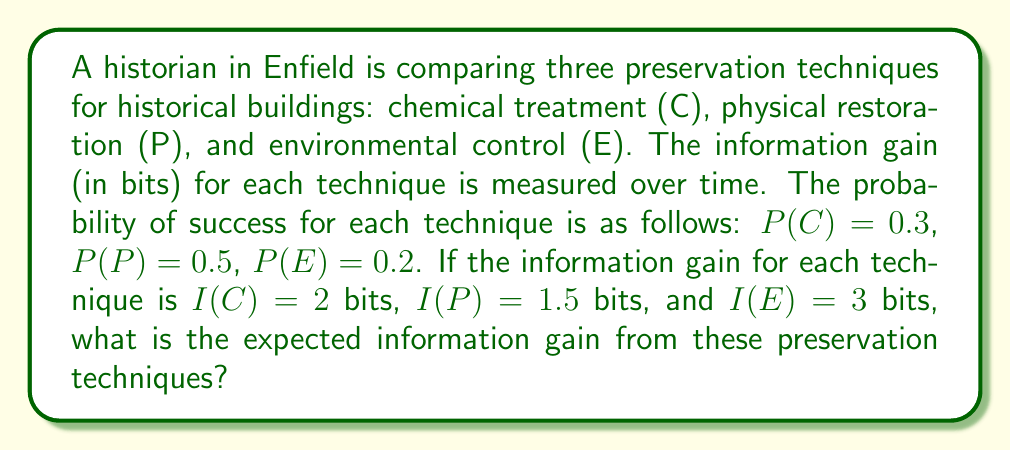What is the answer to this math problem? To solve this problem, we need to calculate the expected information gain using the given probabilities and information gains for each preservation technique. The expected information gain is the sum of the products of each technique's probability and its information gain.

Let's break it down step by step:

1. For chemical treatment (C):
   Probability: P(C) = 0.3
   Information gain: I(C) = 2 bits
   Expected gain from C: $E(C) = P(C) \times I(C) = 0.3 \times 2 = 0.6$ bits

2. For physical restoration (P):
   Probability: P(P) = 0.5
   Information gain: I(P) = 1.5 bits
   Expected gain from P: $E(P) = P(P) \times I(P) = 0.5 \times 1.5 = 0.75$ bits

3. For environmental control (E):
   Probability: P(E) = 0.2
   Information gain: I(E) = 3 bits
   Expected gain from E: $E(E) = P(E) \times I(E) = 0.2 \times 3 = 0.6$ bits

Now, we sum up the expected gains from all three techniques to get the total expected information gain:

$$\text{Total Expected Gain} = E(C) + E(P) + E(E)$$
$$= 0.6 + 0.75 + 0.6$$
$$= 1.95 \text{ bits}$$

Therefore, the expected information gain from these preservation techniques is 1.95 bits.
Answer: 1.95 bits 